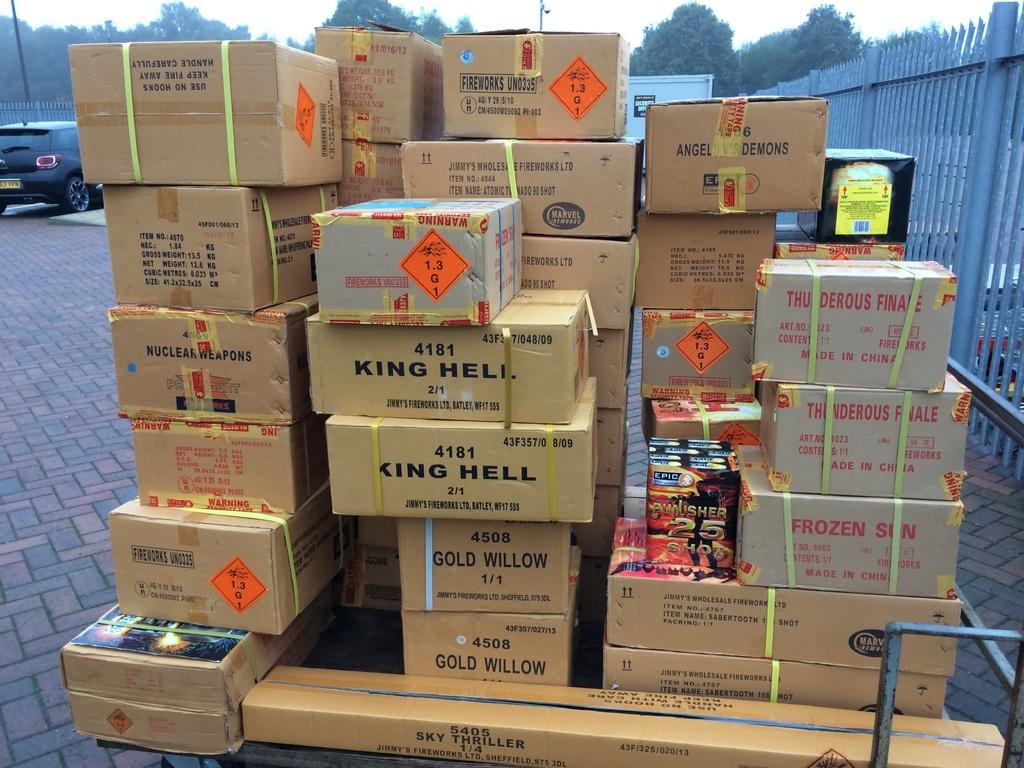What word is after king on the boxes?
Provide a succinct answer. Hell. What colour is the willow?
Your answer should be very brief. Gold. 